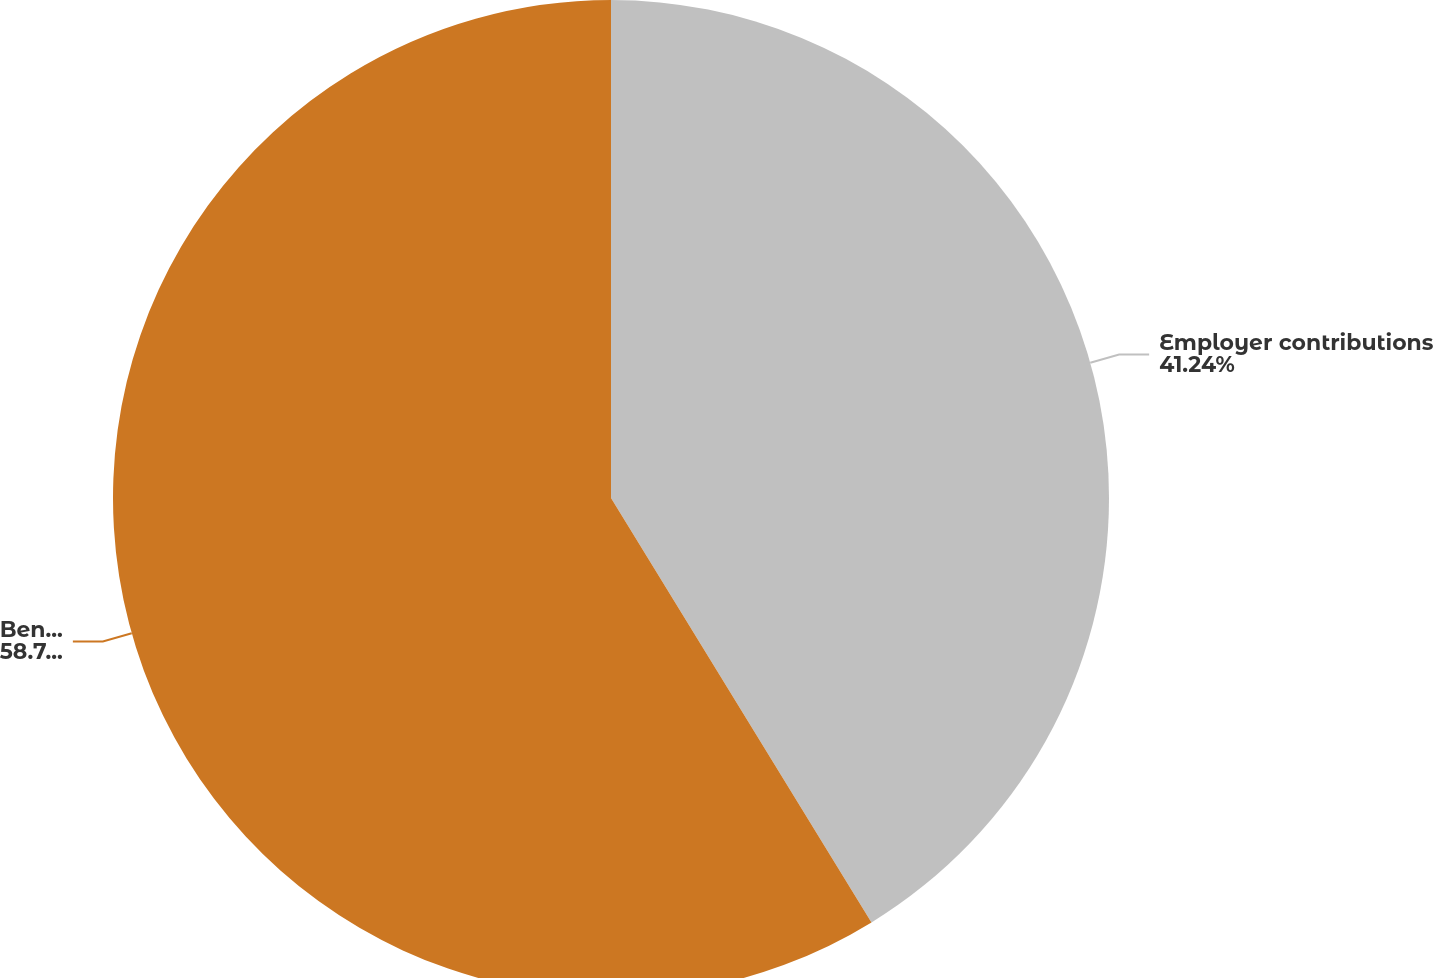<chart> <loc_0><loc_0><loc_500><loc_500><pie_chart><fcel>Employer contributions<fcel>Benefits paid (includes lump<nl><fcel>41.24%<fcel>58.76%<nl></chart> 